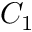<formula> <loc_0><loc_0><loc_500><loc_500>C _ { 1 }</formula> 